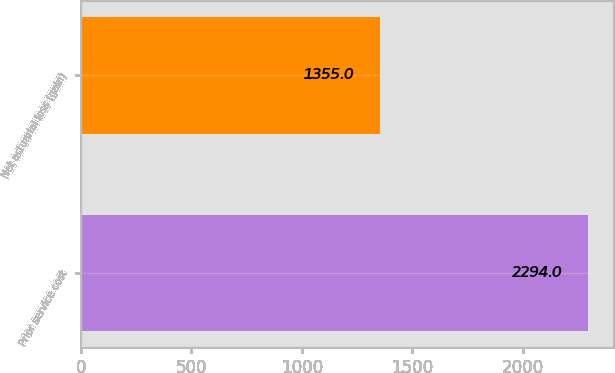Convert chart to OTSL. <chart><loc_0><loc_0><loc_500><loc_500><bar_chart><fcel>Prior service cost<fcel>Net actuarial loss (gain)<nl><fcel>2294<fcel>1355<nl></chart> 